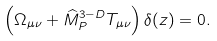Convert formula to latex. <formula><loc_0><loc_0><loc_500><loc_500>\left ( \Omega _ { \mu \nu } + { \widehat { M } } _ { P } ^ { 3 - D } T _ { \mu \nu } \right ) \delta ( z ) = 0 .</formula> 